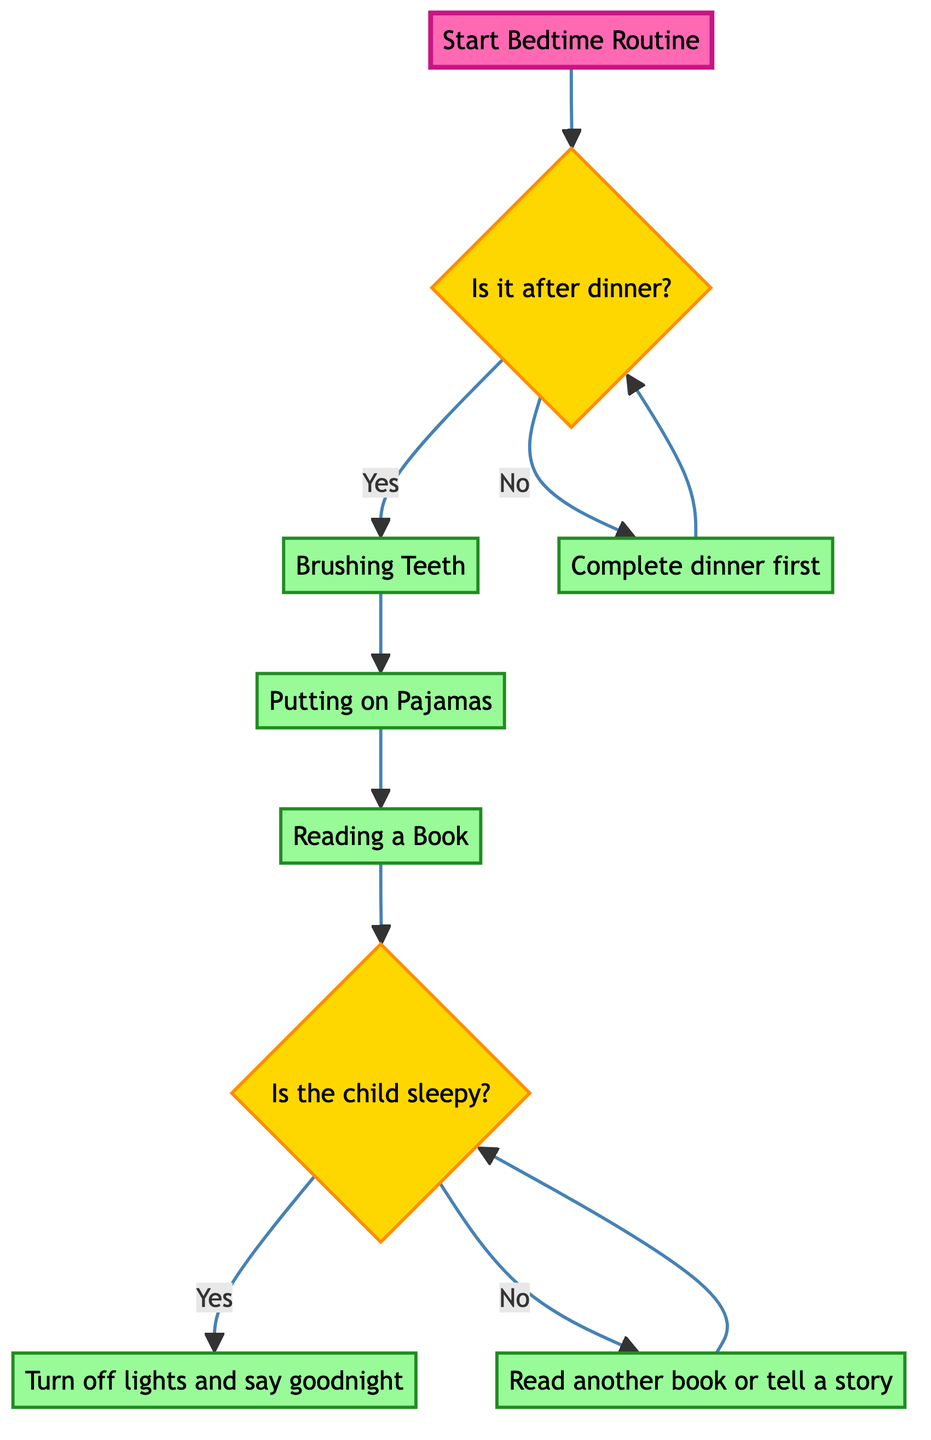What is the first action in the bedtime routine? The first action in the bedtime routine is represented after the question regarding dinner. If it is after dinner, the next action is "Brushing Teeth."
Answer: Brushing Teeth How many actions are there in the bedtime routine? The diagram consists of a sequence of actions after the initial condition. The actions are "Brushing Teeth," "Putting on Pajamas," "Reading a Book," "Turn off lights and say goodnight," and "Read another book or tell a story." Therefore, there are five actions.
Answer: Five What happens if the child is not sleepy? If the child is not sleepy, the decision leads to the action "Read another book or tell a story." From there, it loops back to the question "Is the child sleepy?" to reassess the child's sleepiness.
Answer: Read another book or tell a story What is the last action in the decision tree? The last action occurs when the child is determined to be sleepy, leading to "Turn off lights and say goodnight." There are no further actions after this, indicating it is the end of the routine.
Answer: Turn off lights and say goodnight What do you do first if it is not after dinner? If it is not after dinner, the first action is to "Complete dinner first," after which the decision process restarts at "Is it after dinner?"
Answer: Complete dinner first 